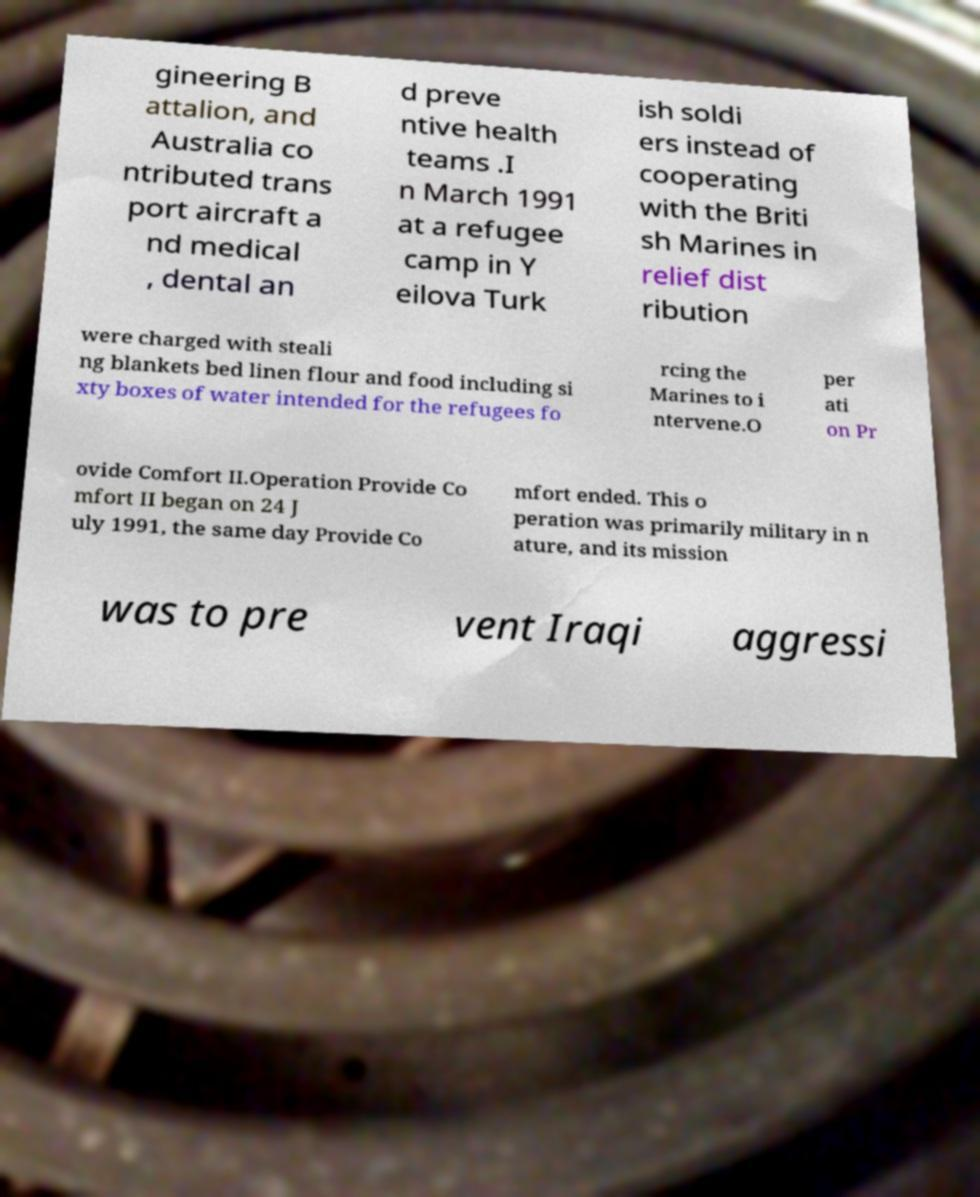What messages or text are displayed in this image? I need them in a readable, typed format. gineering B attalion, and Australia co ntributed trans port aircraft a nd medical , dental an d preve ntive health teams .I n March 1991 at a refugee camp in Y eilova Turk ish soldi ers instead of cooperating with the Briti sh Marines in relief dist ribution were charged with steali ng blankets bed linen flour and food including si xty boxes of water intended for the refugees fo rcing the Marines to i ntervene.O per ati on Pr ovide Comfort II.Operation Provide Co mfort II began on 24 J uly 1991, the same day Provide Co mfort ended. This o peration was primarily military in n ature, and its mission was to pre vent Iraqi aggressi 